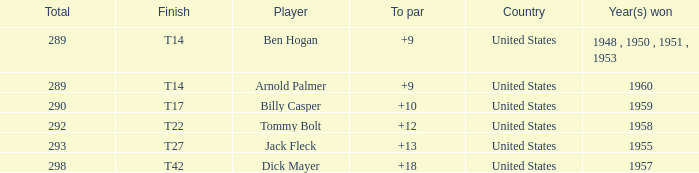What is the total number of Total, when To Par is 12? 1.0. 